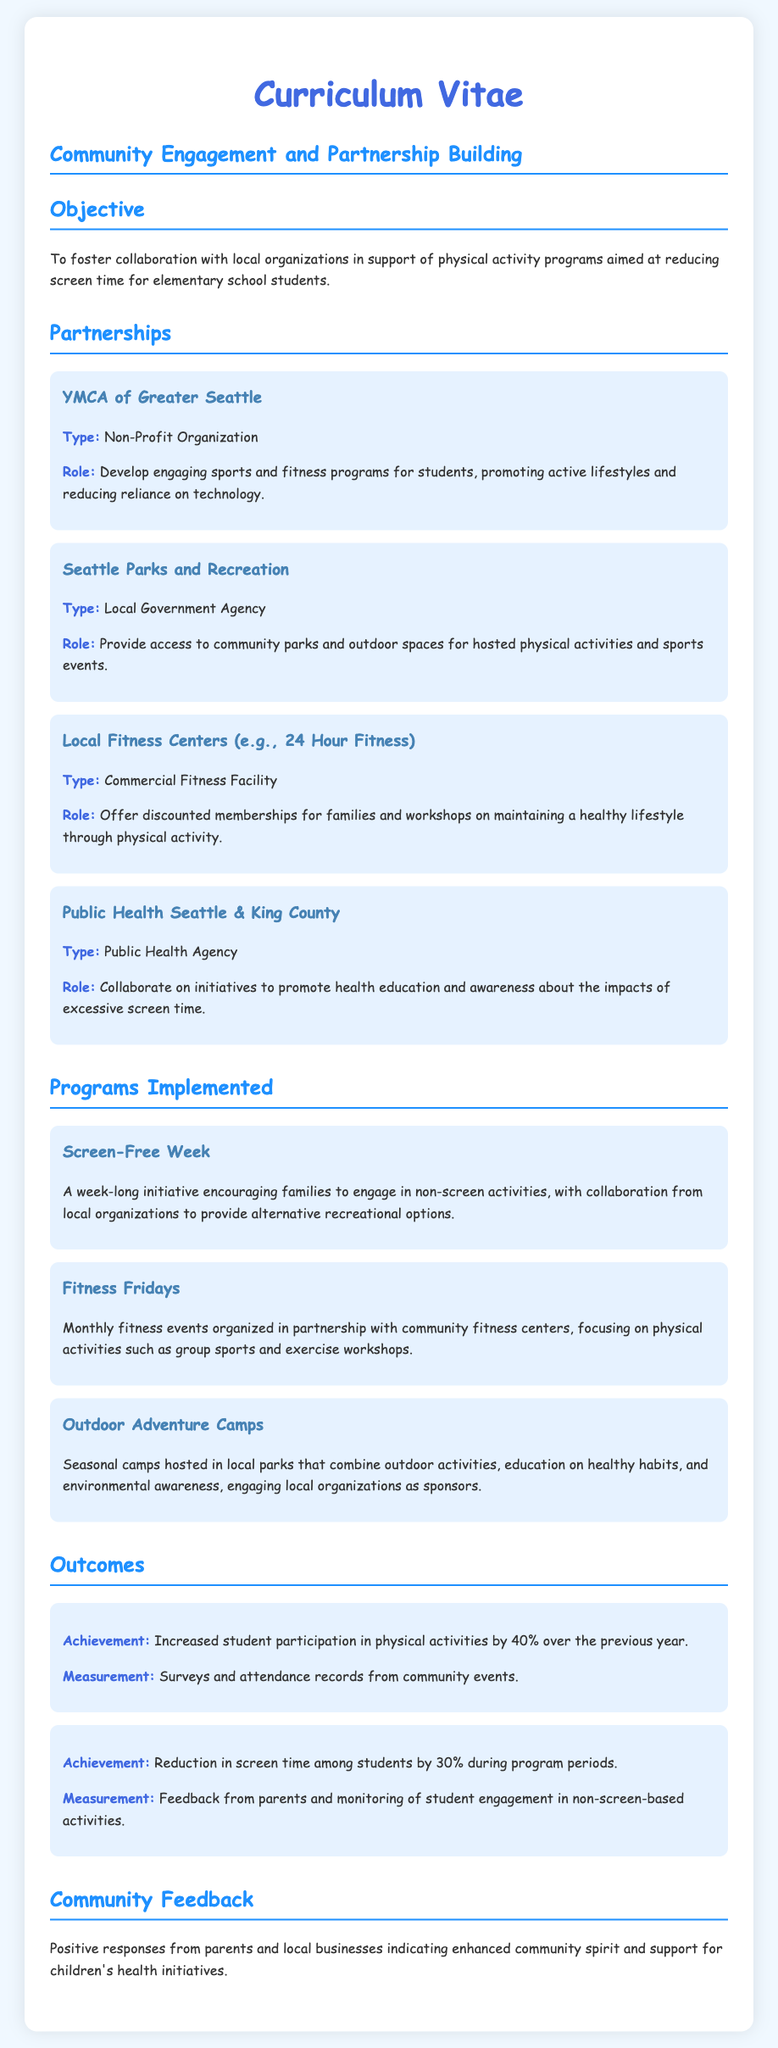What is the name of the first partnership listed? The first partnership mentioned is YMCA of Greater Seattle.
Answer: YMCA of Greater Seattle What percentage increase in physical activity participation is reported? The document states a 40% increase in student participation in physical activities.
Answer: 40% What program encourages families to engage in non-screen activities? The program encouraging non-screen activities is Screen-Free Week.
Answer: Screen-Free Week Which organization provides access to community parks for physical activities? Seattle Parks and Recreation is the organization that provides access to community parks.
Answer: Seattle Parks and Recreation What is the main objective of the document? The objective is to foster collaboration with local organizations to support physical activity programs.
Answer: Foster collaboration with local organizations How many programs focused on reducing screen time are detailed in the document? There are three programs mentioned that focus on reducing screen time.
Answer: Three What is the role of Public Health Seattle & King County? Their role is to collaborate on health education and awareness initiatives regarding excessive screen time.
Answer: Collaborate on health education initiatives What feedback was received from the community? The document indicates positive responses from parents and local businesses.
Answer: Positive responses What type of document is this? This is a Curriculum Vitae focusing on community engagement and partnership building.
Answer: Curriculum Vitae 